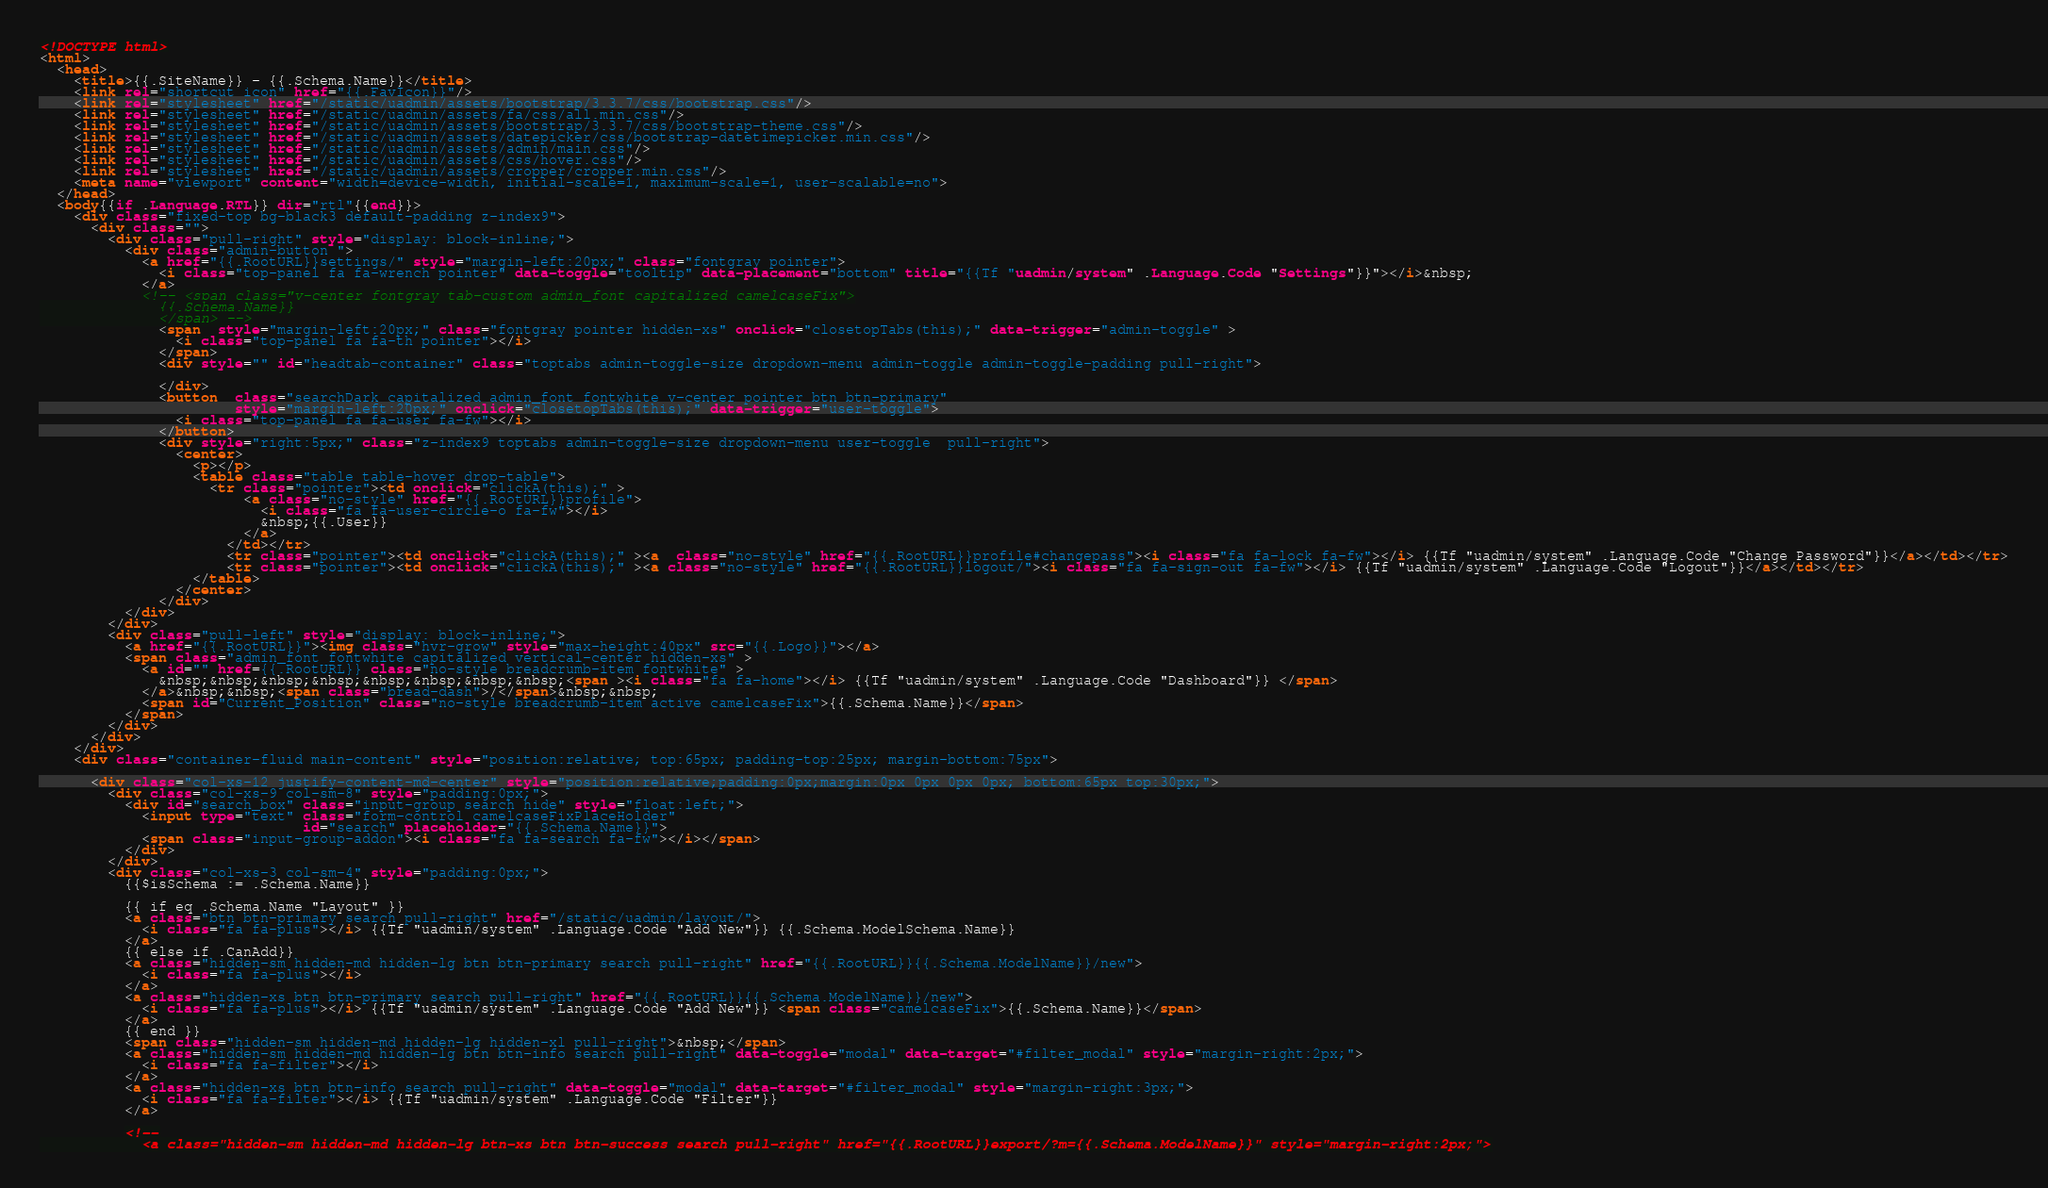<code> <loc_0><loc_0><loc_500><loc_500><_HTML_><!DOCTYPE html>
<html>
  <head>
    <title>{{.SiteName}} - {{.Schema.Name}}</title>
    <link rel="shortcut icon" href="{{.FavIcon}}"/>
    <link rel="stylesheet" href="/static/uadmin/assets/bootstrap/3.3.7/css/bootstrap.css"/>
    <link rel="stylesheet" href="/static/uadmin/assets/fa/css/all.min.css"/>
    <link rel="stylesheet" href="/static/uadmin/assets/bootstrap/3.3.7/css/bootstrap-theme.css"/>
    <link rel="stylesheet" href="/static/uadmin/assets/datepicker/css/bootstrap-datetimepicker.min.css"/>
    <link rel="stylesheet" href="/static/uadmin/assets/admin/main.css"/>
    <link rel="stylesheet" href="/static/uadmin/assets/css/hover.css"/>
    <link rel="stylesheet" href="/static/uadmin/assets/cropper/cropper.min.css"/>
    <meta name="viewport" content="width=device-width, initial-scale=1, maximum-scale=1, user-scalable=no">
  </head>
  <body{{if .Language.RTL}} dir="rtl"{{end}}>
    <div class="fixed-top bg-black3 default-padding z-index9">
      <div class="">
        <div class="pull-right" style="display: block-inline;">
          <div class="admin-button ">
            <a href="{{.RootURL}}settings/" style="margin-left:20px;" class="fontgray pointer">
              <i class="top-panel fa fa-wrench pointer" data-toggle="tooltip" data-placement="bottom" title="{{Tf "uadmin/system" .Language.Code "Settings"}}"></i>&nbsp;
            </a>
            <!-- <span class="v-center fontgray tab-custom admin_font capitalized camelcaseFix">
              {{.Schema.Name}}
              </span> -->
              <span  style="margin-left:20px;" class="fontgray pointer hidden-xs" onclick="closetopTabs(this);" data-trigger="admin-toggle" >
                <i class="top-panel fa fa-th pointer"></i>
              </span>
              <div style="" id="headtab-container" class="toptabs admin-toggle-size dropdown-menu admin-toggle admin-toggle-padding pull-right">

              </div>
              <button  class="searchDark capitalized admin_font fontwhite v-center pointer btn btn-primary"
                       style="margin-left:20px;" onclick="closetopTabs(this);" data-trigger="user-toggle">
                <i class="top-panel fa fa-user fa-fw"></i>
              </button>
              <div style="right:5px;" class="z-index9 toptabs admin-toggle-size dropdown-menu user-toggle  pull-right">
                <center>
                  <p></p>
                  <table class="table table-hover drop-table">
                    <tr class="pointer"><td onclick="clickA(this);" >
                        <a class="no-style" href="{{.RootURL}}profile">
                          <i class="fa fa-user-circle-o fa-fw"></i>
                          &nbsp;{{.User}}
                        </a>
                      </td></tr>
                      <tr class="pointer"><td onclick="clickA(this);" ><a  class="no-style" href="{{.RootURL}}profile#changepass"><i class="fa fa-lock fa-fw"></i> {{Tf "uadmin/system" .Language.Code "Change Password"}}</a></td></tr>
                      <tr class="pointer"><td onclick="clickA(this);" ><a class="no-style" href="{{.RootURL}}logout/"><i class="fa fa-sign-out fa-fw"></i> {{Tf "uadmin/system" .Language.Code "Logout"}}</a></td></tr>
                  </table>
                </center>
              </div>
          </div>
        </div>
        <div class="pull-left" style="display: block-inline;">
          <a href="{{.RootURL}}"><img class="hvr-grow" style="max-height:40px" src="{{.Logo}}"></a>
          <span class="admin_font fontwhite capitalized vertical-center hidden-xs" >
            <a id="" href={{.RootURL}} class="no-style breadcrumb-item fontwhite" >
              &nbsp;&nbsp;&nbsp;&nbsp;&nbsp;&nbsp;&nbsp;&nbsp;<span ><i class="fa fa-home"></i> {{Tf "uadmin/system" .Language.Code "Dashboard"}} </span>
            </a>&nbsp;&nbsp;<span class="bread-dash">/</span>&nbsp;&nbsp;
            <span id="Current_Position" class="no-style breadcrumb-item active camelcaseFix">{{.Schema.Name}}</span>
          </span>
        </div>
      </div>
    </div>
    <div class="container-fluid main-content" style="position:relative; top:65px; padding-top:25px; margin-bottom:75px">

      <div class="col-xs-12 justify-content-md-center" style="position:relative;padding:0px;margin:0px 0px 0px 0px; bottom:65px top:30px;">
        <div class="col-xs-9 col-sm-8" style="padding:0px;">
          <div id="search_box" class="input-group search hide" style="float:left;">
            <input type="text" class="form-control camelcaseFixPlaceHolder"
                               id="search" placeholder="{{.Schema.Name}}">
            <span class="input-group-addon"><i class="fa fa-search fa-fw"></i></span>
          </div>
        </div>
        <div class="col-xs-3 col-sm-4" style="padding:0px;">
          {{$isSchema := .Schema.Name}}

          {{ if eq .Schema.Name "Layout" }}
          <a class="btn btn-primary search pull-right" href="/static/uadmin/layout/">
            <i class="fa fa-plus"></i> {{Tf "uadmin/system" .Language.Code "Add New"}} {{.Schema.ModelSchema.Name}}
          </a>
          {{ else if .CanAdd}}
          <a class="hidden-sm hidden-md hidden-lg btn btn-primary search pull-right" href="{{.RootURL}}{{.Schema.ModelName}}/new">
            <i class="fa fa-plus"></i>
          </a>
          <a class="hidden-xs btn btn-primary search pull-right" href="{{.RootURL}}{{.Schema.ModelName}}/new">
            <i class="fa fa-plus"></i> {{Tf "uadmin/system" .Language.Code "Add New"}} <span class="camelcaseFix">{{.Schema.Name}}</span>
          </a>
          {{ end }}
          <span class="hidden-sm hidden-md hidden-lg hidden-xl pull-right">&nbsp;</span>
          <a class="hidden-sm hidden-md hidden-lg btn btn-info search pull-right" data-toggle="modal" data-target="#filter_modal" style="margin-right:2px;">
            <i class="fa fa-filter"></i>
          </a>
          <a class="hidden-xs btn btn-info search pull-right" data-toggle="modal" data-target="#filter_modal" style="margin-right:3px;">
            <i class="fa fa-filter"></i> {{Tf "uadmin/system" .Language.Code "Filter"}}
          </a>

          <!--
            <a class="hidden-sm hidden-md hidden-lg btn-xs btn btn-success search pull-right" href="{{.RootURL}}export/?m={{.Schema.ModelName}}" style="margin-right:2px;"></code> 